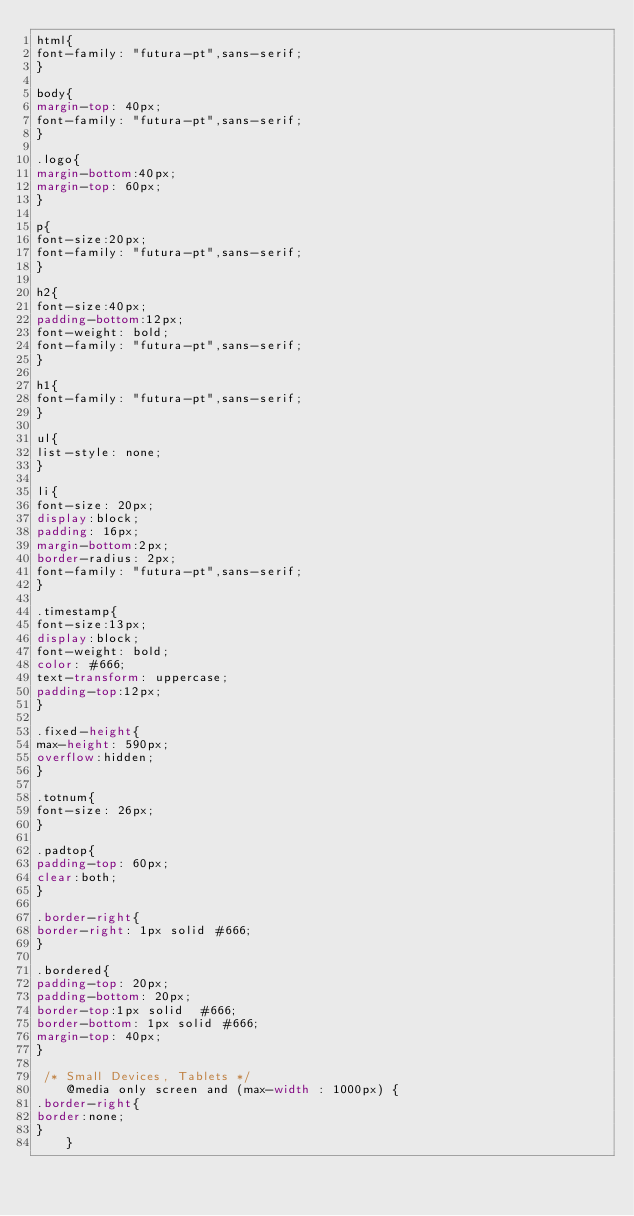<code> <loc_0><loc_0><loc_500><loc_500><_CSS_>html{
font-family: "futura-pt",sans-serif;
}

body{
margin-top: 40px;
font-family: "futura-pt",sans-serif;
}

.logo{
margin-bottom:40px;
margin-top: 60px;
}

p{
font-size:20px;
font-family: "futura-pt",sans-serif;	
}

h2{
font-size:40px;
padding-bottom:12px;
font-weight: bold;
font-family: "futura-pt",sans-serif;
}

h1{
font-family: "futura-pt",sans-serif;
}

ul{
list-style: none;
}

li{
font-size: 20px;
display:block;
padding: 16px;
margin-bottom:2px;
border-radius: 2px;
font-family: "futura-pt",sans-serif;
}

.timestamp{
font-size:13px;
display:block;
font-weight: bold;
color: #666;
text-transform: uppercase;
padding-top:12px;
}

.fixed-height{
max-height: 590px;
overflow:hidden;
}

.totnum{
font-size: 26px;
}

.padtop{
padding-top: 60px;
clear:both;
}

.border-right{
border-right: 1px solid #666;
}

.bordered{
padding-top: 20px;
padding-bottom: 20px;
border-top:1px solid  #666;
border-bottom: 1px solid #666;
margin-top: 40px;
}

 /* Small Devices, Tablets */
    @media only screen and (max-width : 1000px) {
.border-right{
border:none;
}
    }
</code> 